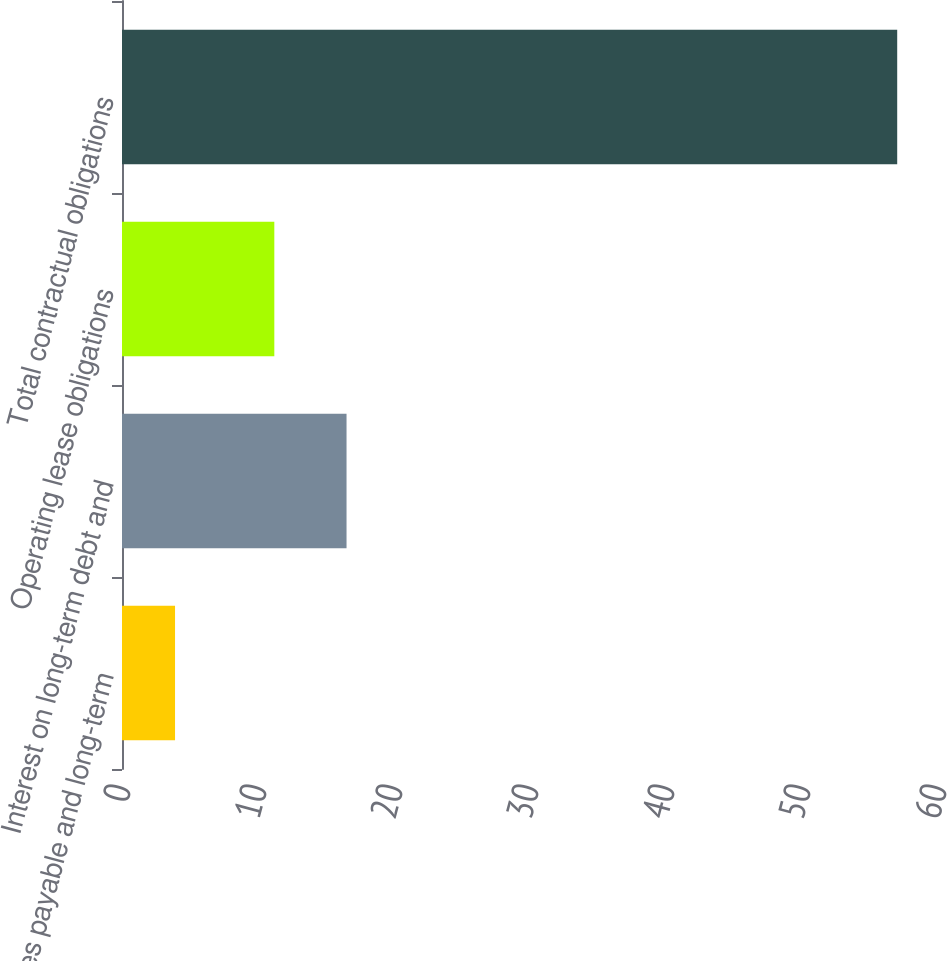Convert chart. <chart><loc_0><loc_0><loc_500><loc_500><bar_chart><fcel>Notes payable and long-term<fcel>Interest on long-term debt and<fcel>Operating lease obligations<fcel>Total contractual obligations<nl><fcel>3.9<fcel>16.51<fcel>11.2<fcel>57<nl></chart> 